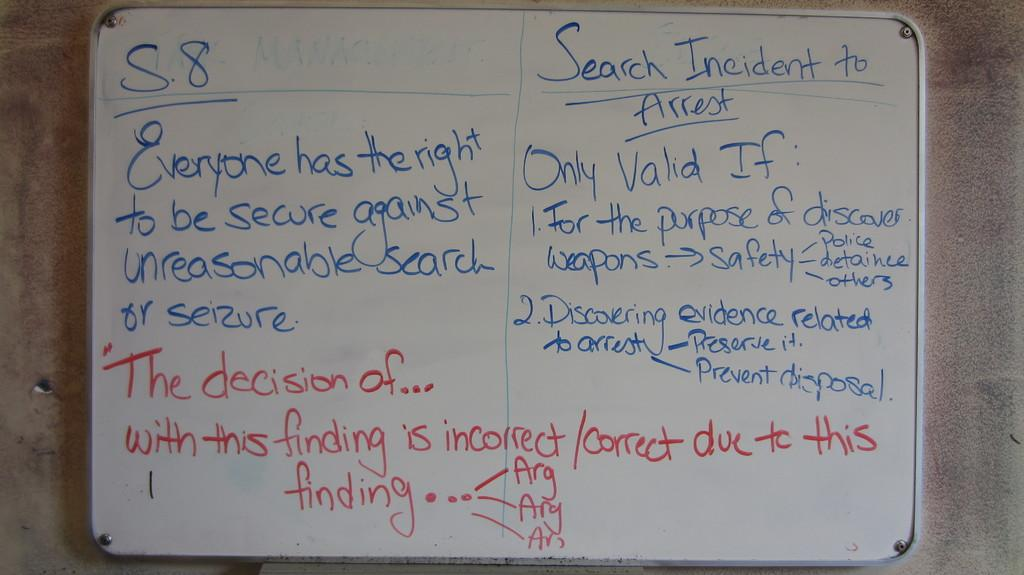<image>
Present a compact description of the photo's key features. The words "Search Incident to Arrest" in underlined in blue on the whiteboard. 